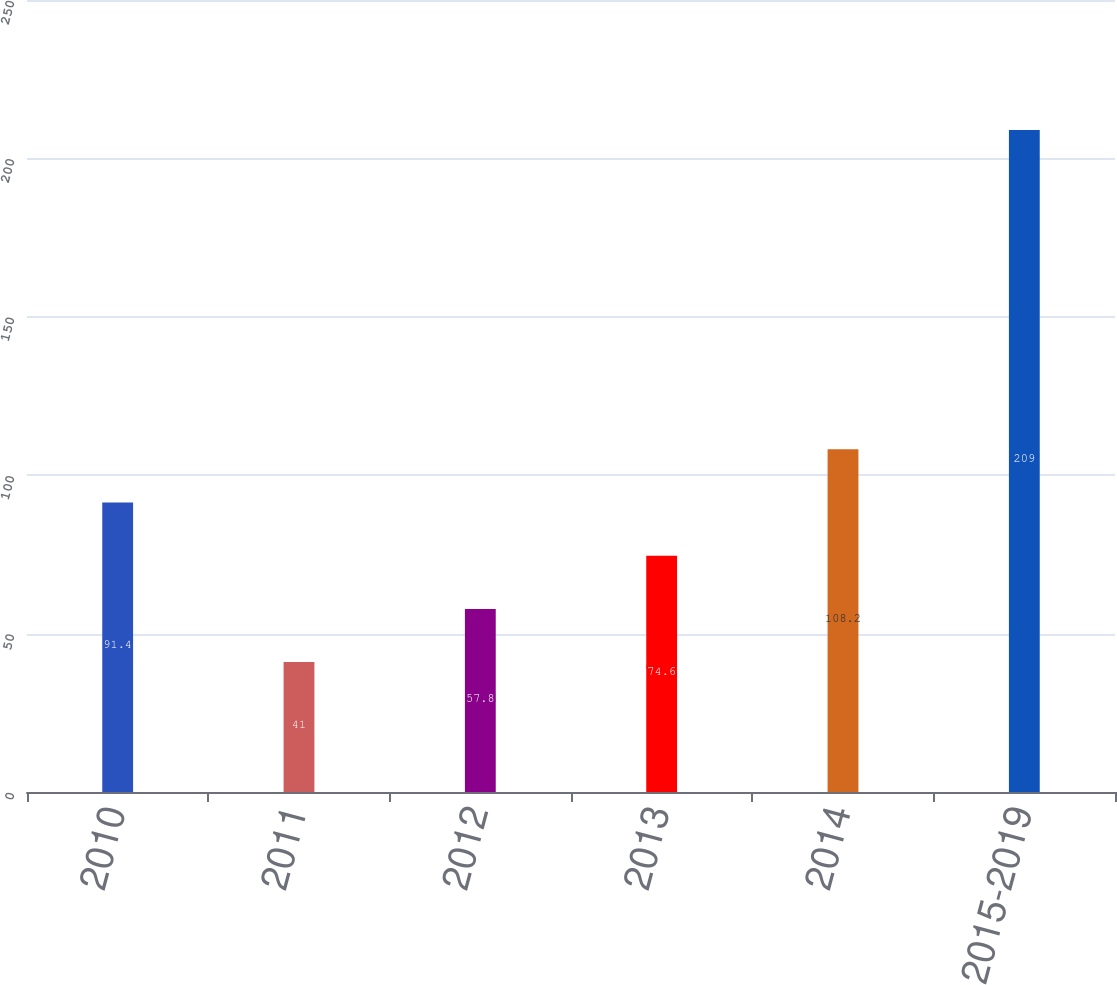<chart> <loc_0><loc_0><loc_500><loc_500><bar_chart><fcel>2010<fcel>2011<fcel>2012<fcel>2013<fcel>2014<fcel>2015-2019<nl><fcel>91.4<fcel>41<fcel>57.8<fcel>74.6<fcel>108.2<fcel>209<nl></chart> 